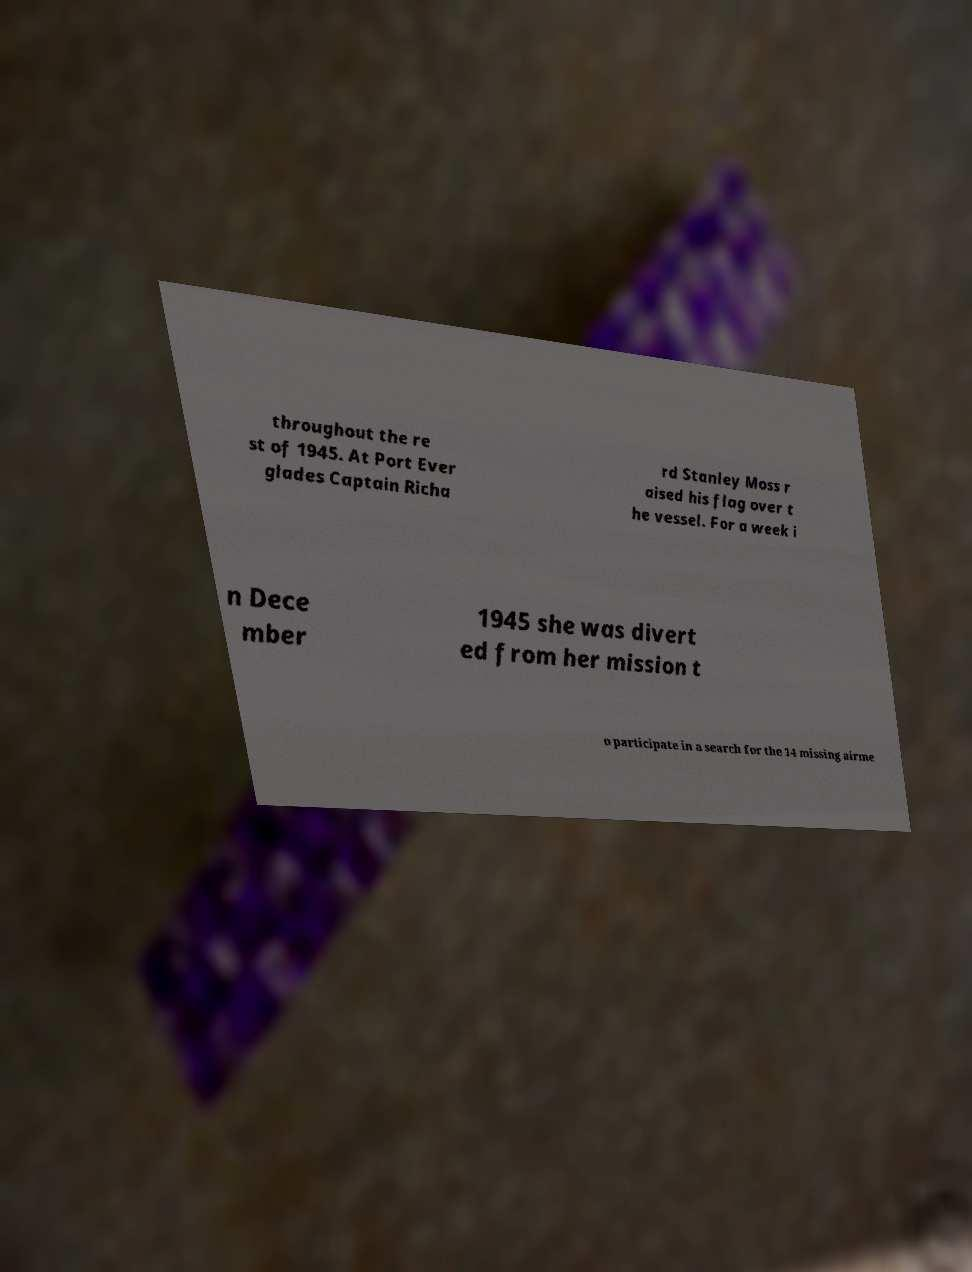Please read and relay the text visible in this image. What does it say? throughout the re st of 1945. At Port Ever glades Captain Richa rd Stanley Moss r aised his flag over t he vessel. For a week i n Dece mber 1945 she was divert ed from her mission t o participate in a search for the 14 missing airme 